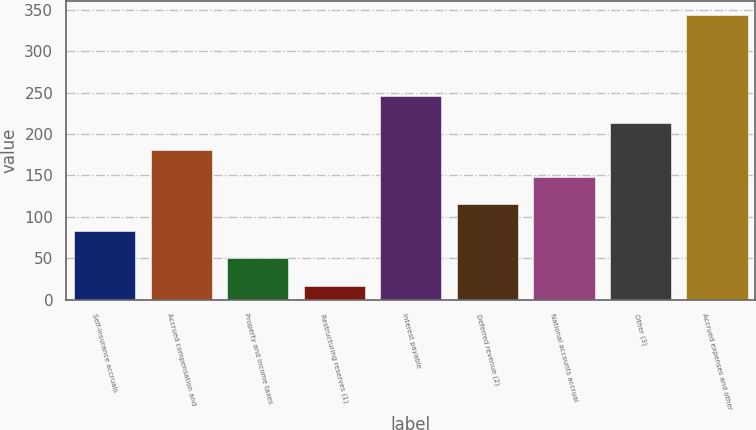Convert chart. <chart><loc_0><loc_0><loc_500><loc_500><bar_chart><fcel>Self-insurance accruals<fcel>Accrued compensation and<fcel>Property and income taxes<fcel>Restructuring reserves (1)<fcel>Interest payable<fcel>Deferred revenue (2)<fcel>National accounts accrual<fcel>Other (3)<fcel>Accrued expenses and other<nl><fcel>82.4<fcel>180.5<fcel>49.7<fcel>17<fcel>245.9<fcel>115.1<fcel>147.8<fcel>213.2<fcel>344<nl></chart> 